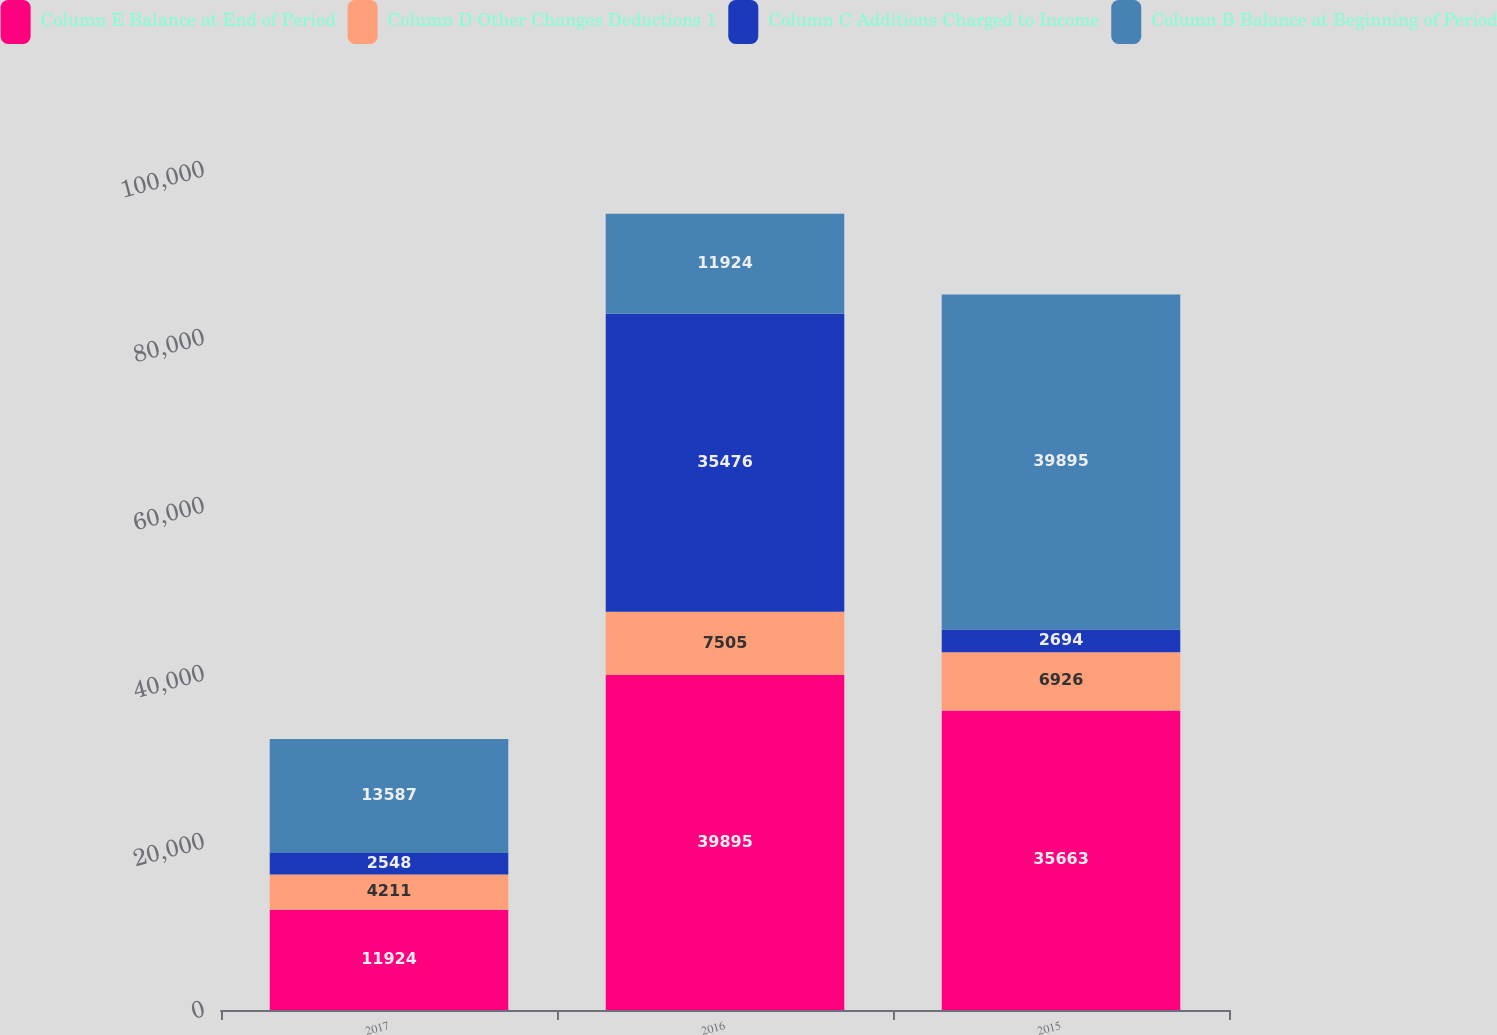Convert chart to OTSL. <chart><loc_0><loc_0><loc_500><loc_500><stacked_bar_chart><ecel><fcel>2017<fcel>2016<fcel>2015<nl><fcel>Column E Balance at End of Period<fcel>11924<fcel>39895<fcel>35663<nl><fcel>Column D Other Changes Deductions 1<fcel>4211<fcel>7505<fcel>6926<nl><fcel>Column C Additions Charged to Income<fcel>2548<fcel>35476<fcel>2694<nl><fcel>Column B Balance at Beginning of Period<fcel>13587<fcel>11924<fcel>39895<nl></chart> 